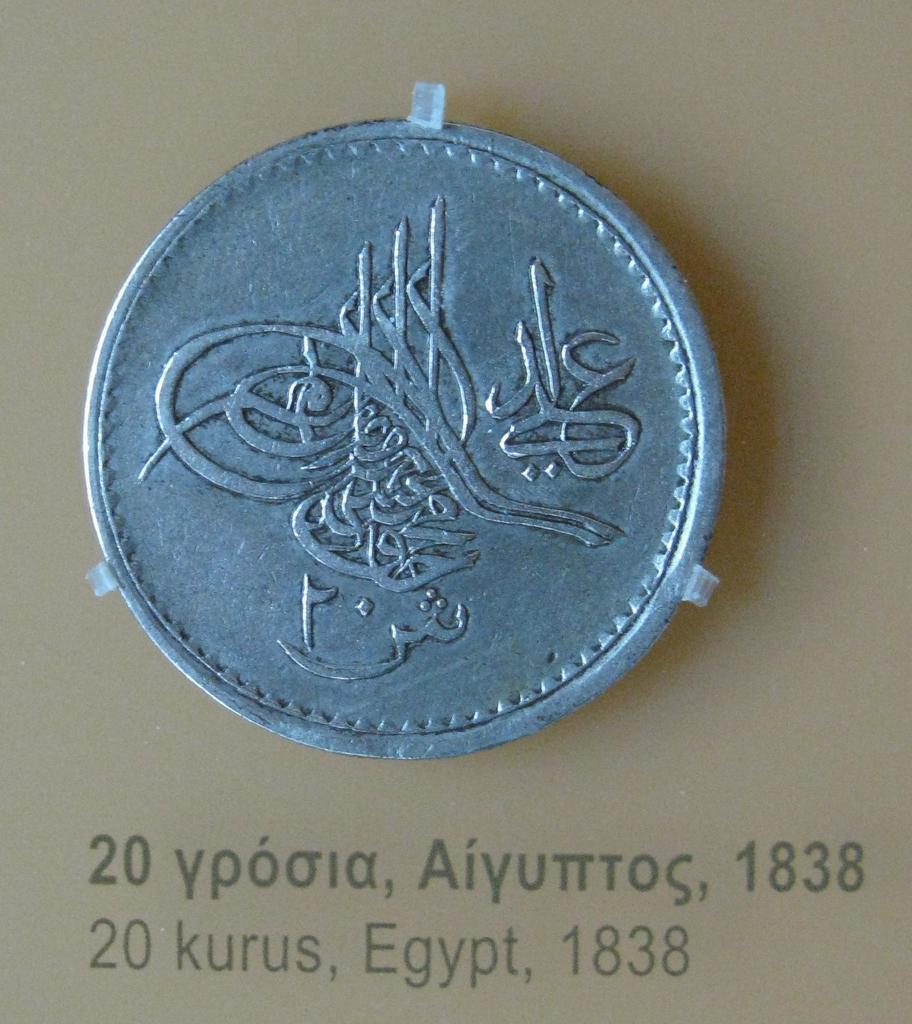What year is this coin from?
Offer a terse response. 1838. What country is the coin from?
Give a very brief answer. Egypt. 